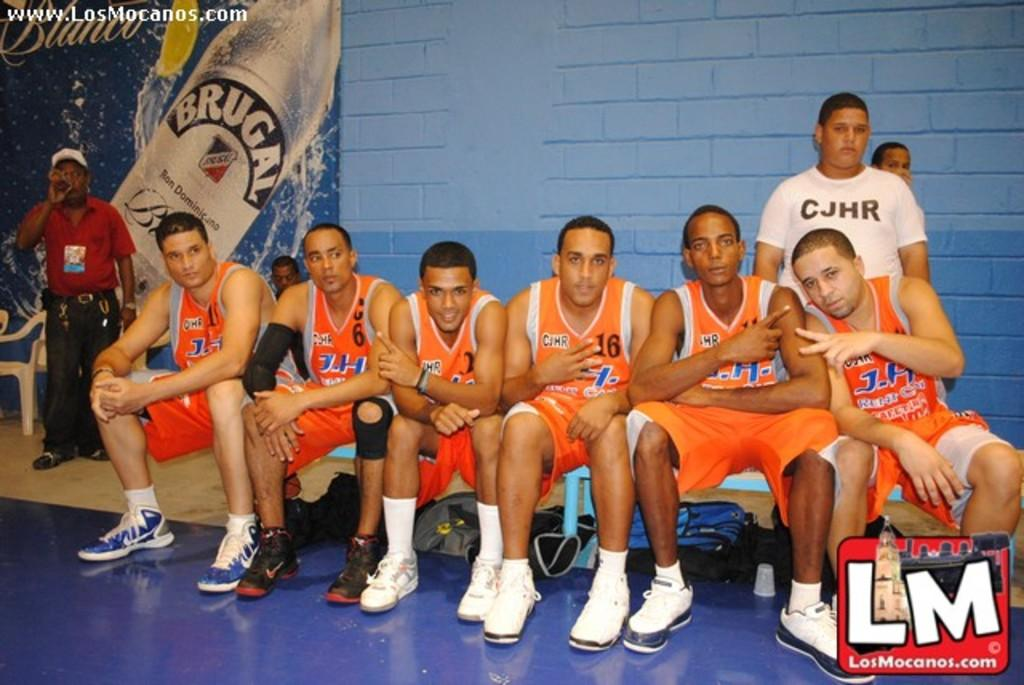<image>
Render a clear and concise summary of the photo. The J.H basketball team is gathered together on a bench. 